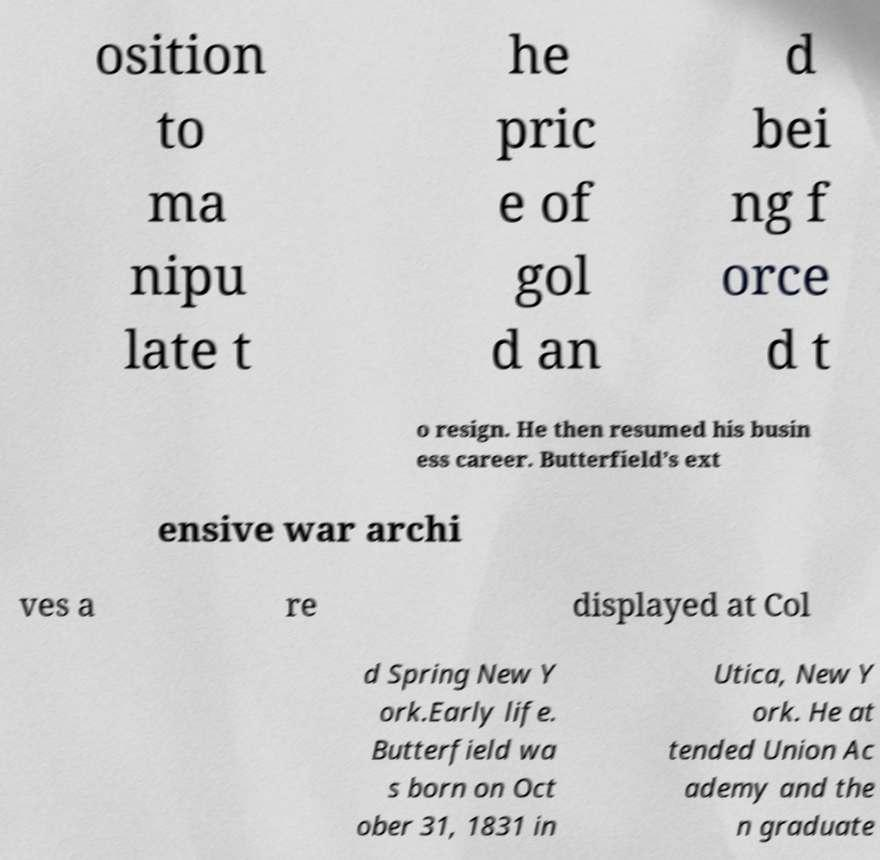Can you accurately transcribe the text from the provided image for me? osition to ma nipu late t he pric e of gol d an d bei ng f orce d t o resign. He then resumed his busin ess career. Butterfield’s ext ensive war archi ves a re displayed at Col d Spring New Y ork.Early life. Butterfield wa s born on Oct ober 31, 1831 in Utica, New Y ork. He at tended Union Ac ademy and the n graduate 